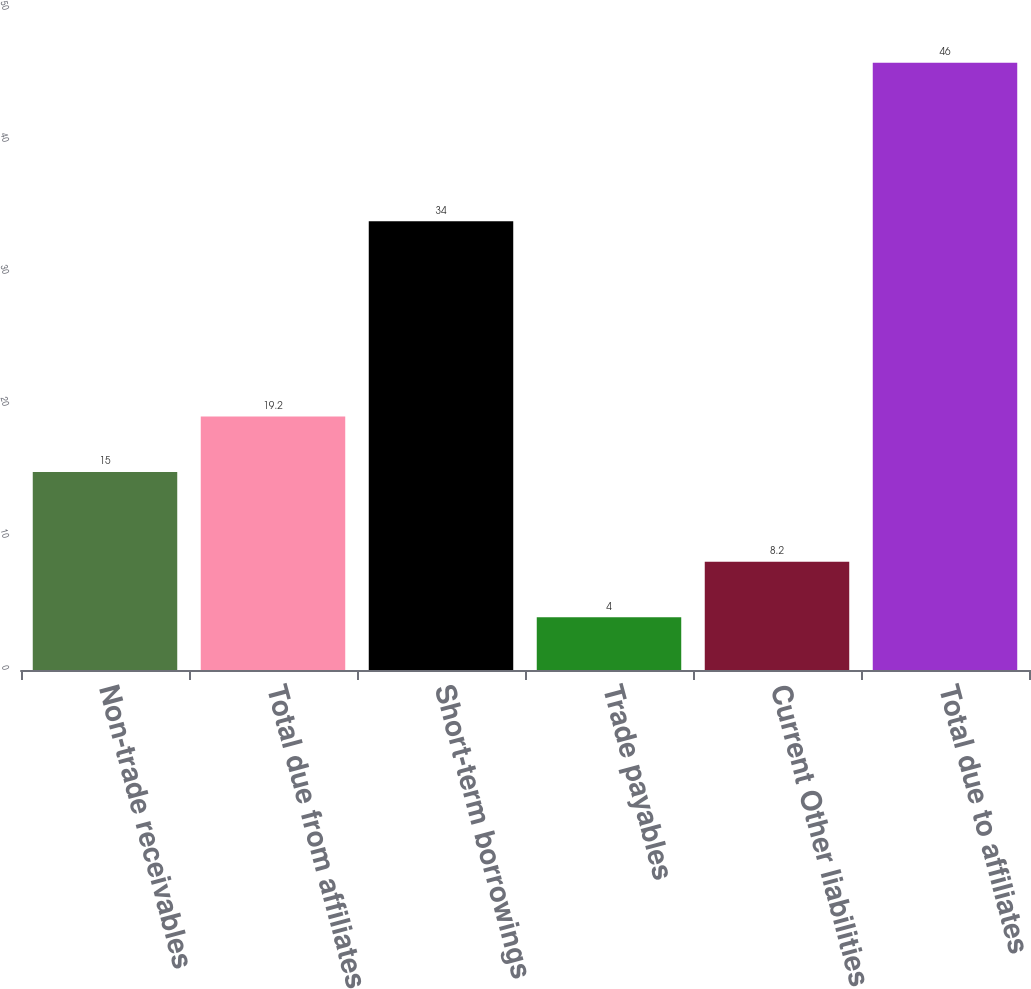Convert chart to OTSL. <chart><loc_0><loc_0><loc_500><loc_500><bar_chart><fcel>Non-trade receivables<fcel>Total due from affiliates<fcel>Short-term borrowings<fcel>Trade payables<fcel>Current Other liabilities<fcel>Total due to affiliates<nl><fcel>15<fcel>19.2<fcel>34<fcel>4<fcel>8.2<fcel>46<nl></chart> 